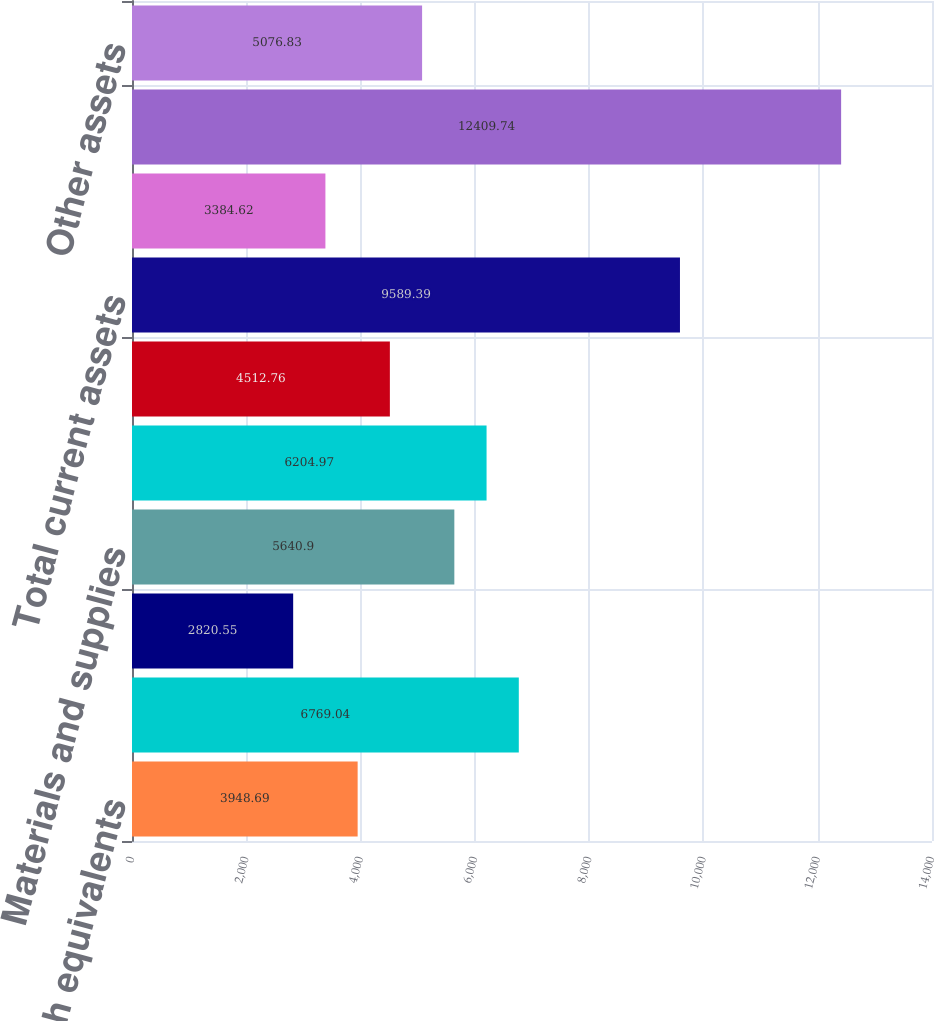Convert chart to OTSL. <chart><loc_0><loc_0><loc_500><loc_500><bar_chart><fcel>Cash and cash equivalents<fcel>Accounts receivable net<fcel>Restricted funds<fcel>Materials and supplies<fcel>Deferred income taxes<fcel>Other current assets<fcel>Total current assets<fcel>Investments<fcel>Property and equipment<fcel>Other assets<nl><fcel>3948.69<fcel>6769.04<fcel>2820.55<fcel>5640.9<fcel>6204.97<fcel>4512.76<fcel>9589.39<fcel>3384.62<fcel>12409.7<fcel>5076.83<nl></chart> 